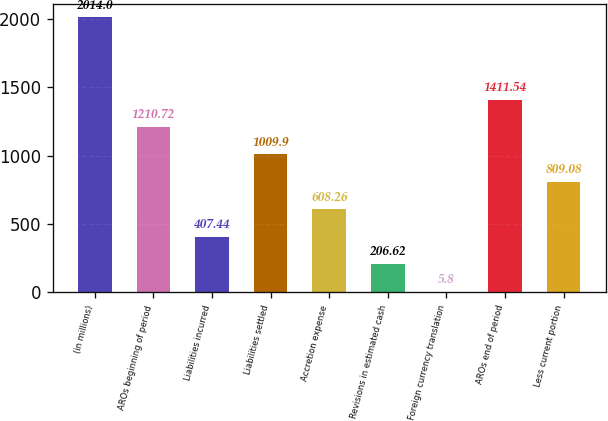Convert chart to OTSL. <chart><loc_0><loc_0><loc_500><loc_500><bar_chart><fcel>(in millions)<fcel>AROs beginning of period<fcel>Liabilities incurred<fcel>Liabilities settled<fcel>Accretion expense<fcel>Revisions in estimated cash<fcel>Foreign currency translation<fcel>AROs end of period<fcel>Less current portion<nl><fcel>2014<fcel>1210.72<fcel>407.44<fcel>1009.9<fcel>608.26<fcel>206.62<fcel>5.8<fcel>1411.54<fcel>809.08<nl></chart> 